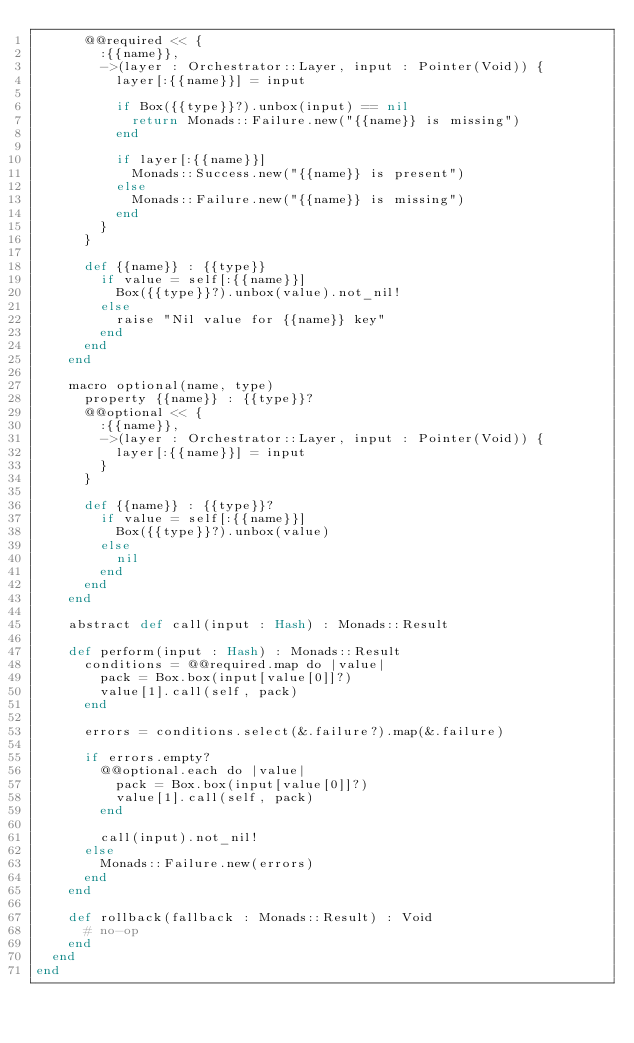<code> <loc_0><loc_0><loc_500><loc_500><_Crystal_>      @@required << {
        :{{name}},
        ->(layer : Orchestrator::Layer, input : Pointer(Void)) {
          layer[:{{name}}] = input

          if Box({{type}}?).unbox(input) == nil
            return Monads::Failure.new("{{name}} is missing")
          end

          if layer[:{{name}}]
            Monads::Success.new("{{name}} is present")
          else
            Monads::Failure.new("{{name}} is missing")
          end
        }
      }

      def {{name}} : {{type}}
        if value = self[:{{name}}]
          Box({{type}}?).unbox(value).not_nil!
        else
          raise "Nil value for {{name}} key"
        end
      end
    end

    macro optional(name, type)
      property {{name}} : {{type}}?
      @@optional << {
        :{{name}},
        ->(layer : Orchestrator::Layer, input : Pointer(Void)) {
          layer[:{{name}}] = input
        }
      }

      def {{name}} : {{type}}?
        if value = self[:{{name}}]
          Box({{type}}?).unbox(value)
        else
          nil
        end
      end
    end

    abstract def call(input : Hash) : Monads::Result

    def perform(input : Hash) : Monads::Result
      conditions = @@required.map do |value|
        pack = Box.box(input[value[0]]?)
        value[1].call(self, pack)
      end

      errors = conditions.select(&.failure?).map(&.failure)

      if errors.empty?
        @@optional.each do |value|
          pack = Box.box(input[value[0]]?)
          value[1].call(self, pack)
        end

        call(input).not_nil!
      else
        Monads::Failure.new(errors)
      end
    end

    def rollback(fallback : Monads::Result) : Void
      # no-op
    end
  end
end
</code> 